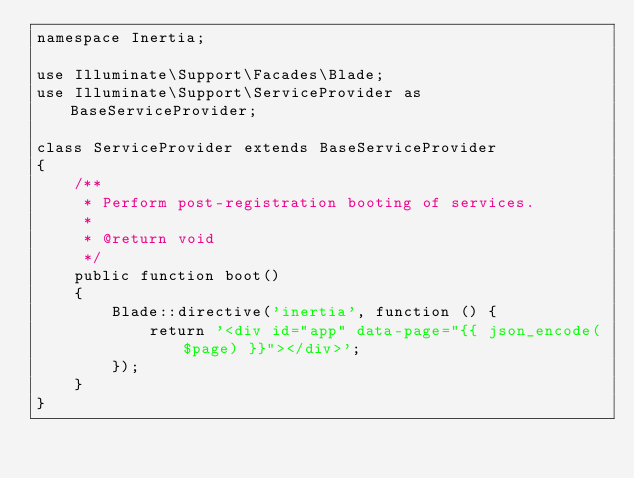Convert code to text. <code><loc_0><loc_0><loc_500><loc_500><_PHP_>namespace Inertia;

use Illuminate\Support\Facades\Blade;
use Illuminate\Support\ServiceProvider as BaseServiceProvider;

class ServiceProvider extends BaseServiceProvider
{
    /**
     * Perform post-registration booting of services.
     *
     * @return void
     */
    public function boot()
    {
        Blade::directive('inertia', function () {
            return '<div id="app" data-page="{{ json_encode($page) }}"></div>';
        });
    }
}
</code> 